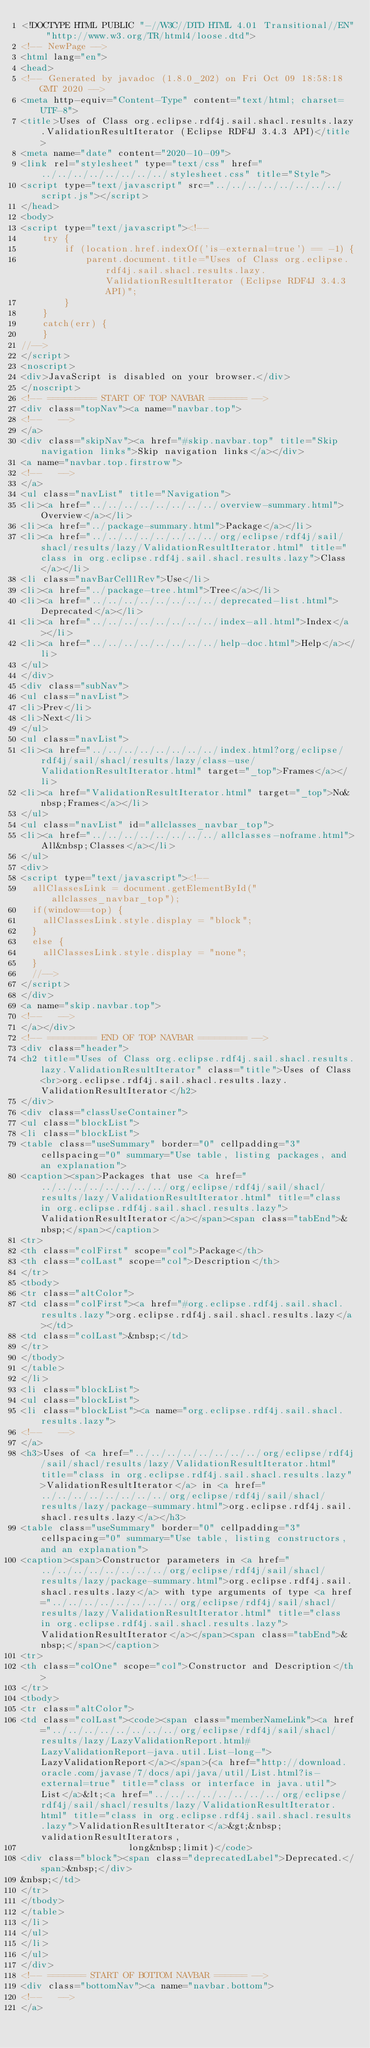<code> <loc_0><loc_0><loc_500><loc_500><_HTML_><!DOCTYPE HTML PUBLIC "-//W3C//DTD HTML 4.01 Transitional//EN" "http://www.w3.org/TR/html4/loose.dtd">
<!-- NewPage -->
<html lang="en">
<head>
<!-- Generated by javadoc (1.8.0_202) on Fri Oct 09 18:58:18 GMT 2020 -->
<meta http-equiv="Content-Type" content="text/html; charset=UTF-8">
<title>Uses of Class org.eclipse.rdf4j.sail.shacl.results.lazy.ValidationResultIterator (Eclipse RDF4J 3.4.3 API)</title>
<meta name="date" content="2020-10-09">
<link rel="stylesheet" type="text/css" href="../../../../../../../../stylesheet.css" title="Style">
<script type="text/javascript" src="../../../../../../../../script.js"></script>
</head>
<body>
<script type="text/javascript"><!--
    try {
        if (location.href.indexOf('is-external=true') == -1) {
            parent.document.title="Uses of Class org.eclipse.rdf4j.sail.shacl.results.lazy.ValidationResultIterator (Eclipse RDF4J 3.4.3 API)";
        }
    }
    catch(err) {
    }
//-->
</script>
<noscript>
<div>JavaScript is disabled on your browser.</div>
</noscript>
<!-- ========= START OF TOP NAVBAR ======= -->
<div class="topNav"><a name="navbar.top">
<!--   -->
</a>
<div class="skipNav"><a href="#skip.navbar.top" title="Skip navigation links">Skip navigation links</a></div>
<a name="navbar.top.firstrow">
<!--   -->
</a>
<ul class="navList" title="Navigation">
<li><a href="../../../../../../../../overview-summary.html">Overview</a></li>
<li><a href="../package-summary.html">Package</a></li>
<li><a href="../../../../../../../../org/eclipse/rdf4j/sail/shacl/results/lazy/ValidationResultIterator.html" title="class in org.eclipse.rdf4j.sail.shacl.results.lazy">Class</a></li>
<li class="navBarCell1Rev">Use</li>
<li><a href="../package-tree.html">Tree</a></li>
<li><a href="../../../../../../../../deprecated-list.html">Deprecated</a></li>
<li><a href="../../../../../../../../index-all.html">Index</a></li>
<li><a href="../../../../../../../../help-doc.html">Help</a></li>
</ul>
</div>
<div class="subNav">
<ul class="navList">
<li>Prev</li>
<li>Next</li>
</ul>
<ul class="navList">
<li><a href="../../../../../../../../index.html?org/eclipse/rdf4j/sail/shacl/results/lazy/class-use/ValidationResultIterator.html" target="_top">Frames</a></li>
<li><a href="ValidationResultIterator.html" target="_top">No&nbsp;Frames</a></li>
</ul>
<ul class="navList" id="allclasses_navbar_top">
<li><a href="../../../../../../../../allclasses-noframe.html">All&nbsp;Classes</a></li>
</ul>
<div>
<script type="text/javascript"><!--
  allClassesLink = document.getElementById("allclasses_navbar_top");
  if(window==top) {
    allClassesLink.style.display = "block";
  }
  else {
    allClassesLink.style.display = "none";
  }
  //-->
</script>
</div>
<a name="skip.navbar.top">
<!--   -->
</a></div>
<!-- ========= END OF TOP NAVBAR ========= -->
<div class="header">
<h2 title="Uses of Class org.eclipse.rdf4j.sail.shacl.results.lazy.ValidationResultIterator" class="title">Uses of Class<br>org.eclipse.rdf4j.sail.shacl.results.lazy.ValidationResultIterator</h2>
</div>
<div class="classUseContainer">
<ul class="blockList">
<li class="blockList">
<table class="useSummary" border="0" cellpadding="3" cellspacing="0" summary="Use table, listing packages, and an explanation">
<caption><span>Packages that use <a href="../../../../../../../../org/eclipse/rdf4j/sail/shacl/results/lazy/ValidationResultIterator.html" title="class in org.eclipse.rdf4j.sail.shacl.results.lazy">ValidationResultIterator</a></span><span class="tabEnd">&nbsp;</span></caption>
<tr>
<th class="colFirst" scope="col">Package</th>
<th class="colLast" scope="col">Description</th>
</tr>
<tbody>
<tr class="altColor">
<td class="colFirst"><a href="#org.eclipse.rdf4j.sail.shacl.results.lazy">org.eclipse.rdf4j.sail.shacl.results.lazy</a></td>
<td class="colLast">&nbsp;</td>
</tr>
</tbody>
</table>
</li>
<li class="blockList">
<ul class="blockList">
<li class="blockList"><a name="org.eclipse.rdf4j.sail.shacl.results.lazy">
<!--   -->
</a>
<h3>Uses of <a href="../../../../../../../../org/eclipse/rdf4j/sail/shacl/results/lazy/ValidationResultIterator.html" title="class in org.eclipse.rdf4j.sail.shacl.results.lazy">ValidationResultIterator</a> in <a href="../../../../../../../../org/eclipse/rdf4j/sail/shacl/results/lazy/package-summary.html">org.eclipse.rdf4j.sail.shacl.results.lazy</a></h3>
<table class="useSummary" border="0" cellpadding="3" cellspacing="0" summary="Use table, listing constructors, and an explanation">
<caption><span>Constructor parameters in <a href="../../../../../../../../org/eclipse/rdf4j/sail/shacl/results/lazy/package-summary.html">org.eclipse.rdf4j.sail.shacl.results.lazy</a> with type arguments of type <a href="../../../../../../../../org/eclipse/rdf4j/sail/shacl/results/lazy/ValidationResultIterator.html" title="class in org.eclipse.rdf4j.sail.shacl.results.lazy">ValidationResultIterator</a></span><span class="tabEnd">&nbsp;</span></caption>
<tr>
<th class="colOne" scope="col">Constructor and Description</th>
</tr>
<tbody>
<tr class="altColor">
<td class="colLast"><code><span class="memberNameLink"><a href="../../../../../../../../org/eclipse/rdf4j/sail/shacl/results/lazy/LazyValidationReport.html#LazyValidationReport-java.util.List-long-">LazyValidationReport</a></span>(<a href="http://download.oracle.com/javase/7/docs/api/java/util/List.html?is-external=true" title="class or interface in java.util">List</a>&lt;<a href="../../../../../../../../org/eclipse/rdf4j/sail/shacl/results/lazy/ValidationResultIterator.html" title="class in org.eclipse.rdf4j.sail.shacl.results.lazy">ValidationResultIterator</a>&gt;&nbsp;validationResultIterators,
                    long&nbsp;limit)</code>
<div class="block"><span class="deprecatedLabel">Deprecated.</span>&nbsp;</div>
&nbsp;</td>
</tr>
</tbody>
</table>
</li>
</ul>
</li>
</ul>
</div>
<!-- ======= START OF BOTTOM NAVBAR ====== -->
<div class="bottomNav"><a name="navbar.bottom">
<!--   -->
</a></code> 